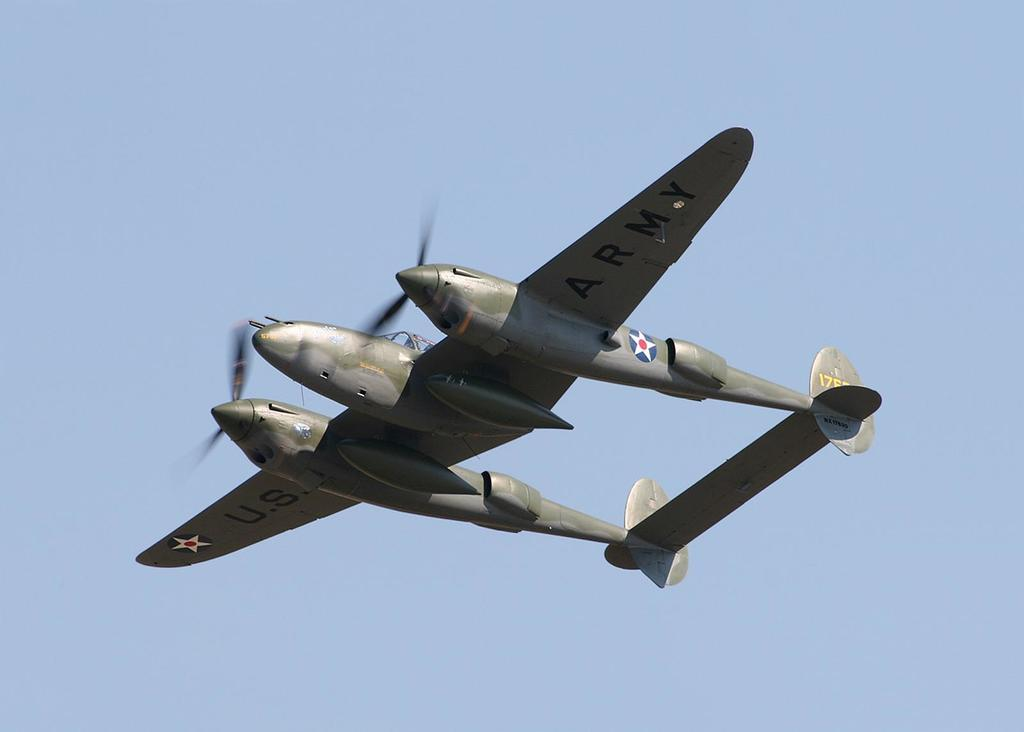What color is the aircraft in the image? The aircraft in the image is green. What is the aircraft doing in the image? The aircraft is flying in the sky. What is the condition of the sky in the image? The sky in the image is clear. How many stone pies can be seen on the aircraft in the image? There are no stone pies present on the aircraft in the image. 